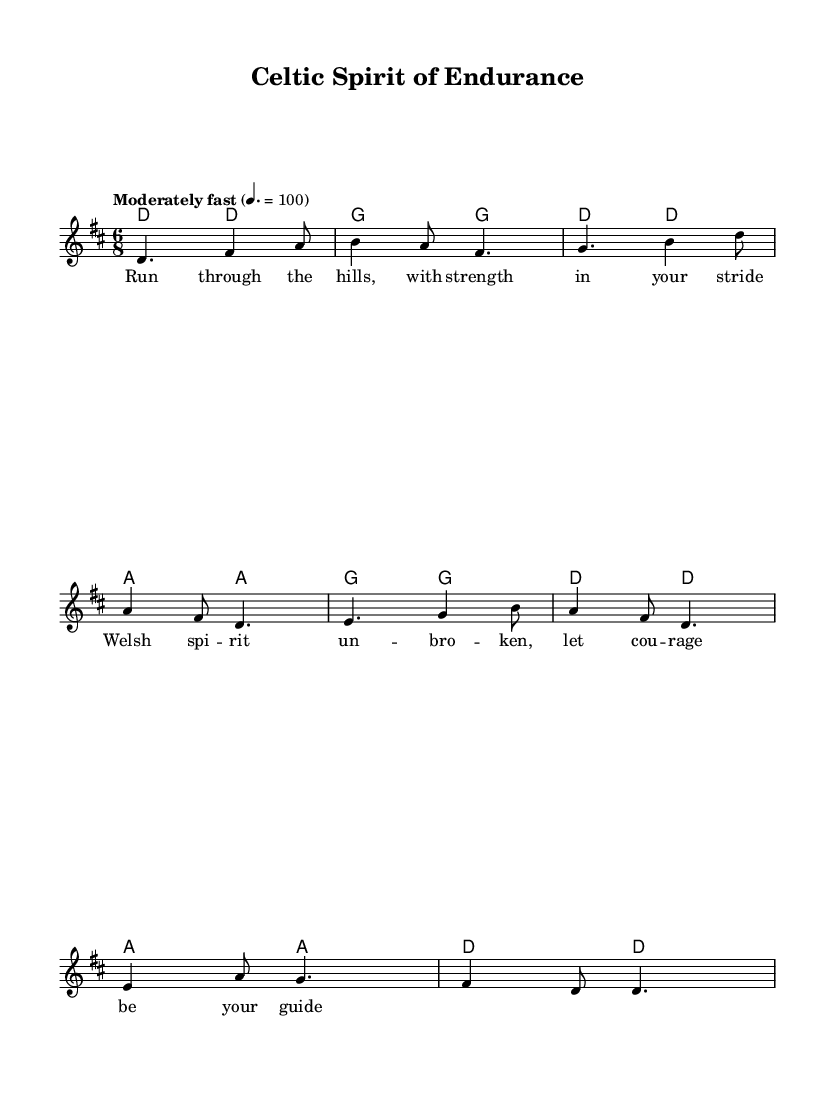What is the key signature of this music? The key signature is D major, which has two sharps: F# and C#. This can be determined by looking at the key indicated at the beginning of the score.
Answer: D major What is the time signature of this piece? The time signature is 6/8, which indicates a compound meter where each measure consists of six eighth notes. This is explicitly stated at the beginning of the score next to the key signature.
Answer: 6/8 What is the tempo marking given in the music? The tempo marking is "Moderately fast" at a speed of 100 beats per minute, as noted in the tempo section at the beginning of the score.
Answer: Moderately fast How many measures are present in the melody? There are eight measures in the melody, which can be counted by observing the bar lines separating the measures in the musical notation.
Answer: Eight What theme do the lyrics of the first verse convey? The lyrics express themes of endurance and courage, as they refer to running through hills with strength and the spirit of Wales guiding one’s courage. This aligns with typical folk themes of perseverance.
Answer: Endurance and courage What is the harmonic structure of the first four measures? The harmonic structure consists of the chords D, G, D, and A in the first four measures, as indicated by the chord symbols written above the melody.
Answer: D, G, D, A What type of musical style does this piece represent? This piece represents traditional Celtic folk music, characterized by its storytelling and themes of endurance, often embracing the spirit and culture of the Welsh.
Answer: Celtic folk music 